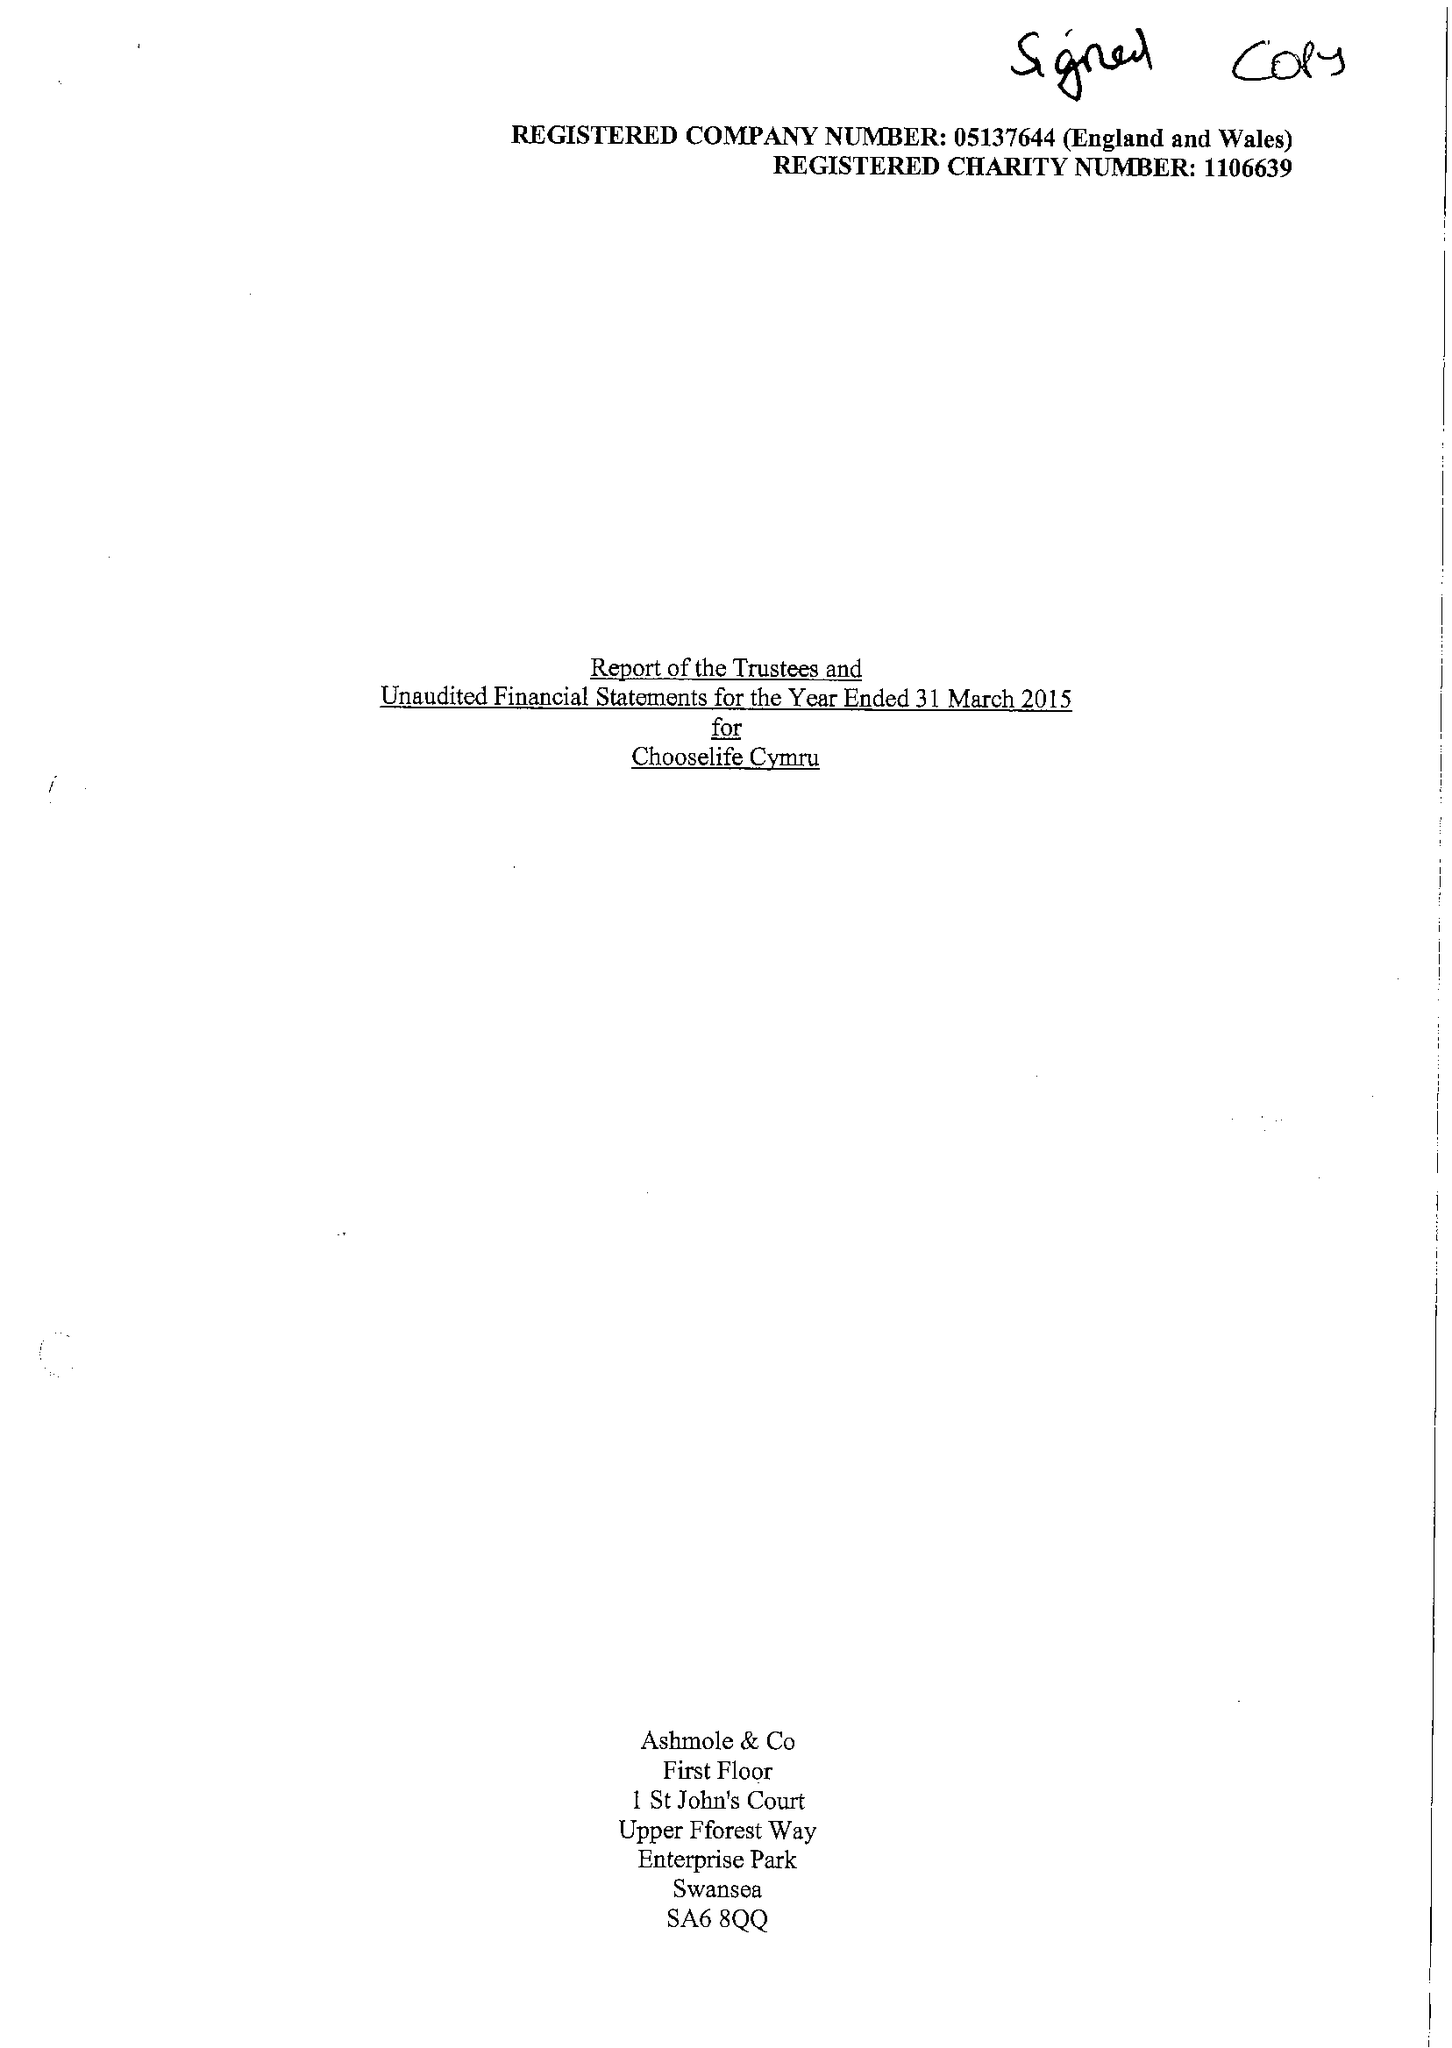What is the value for the spending_annually_in_british_pounds?
Answer the question using a single word or phrase. 391640.00 